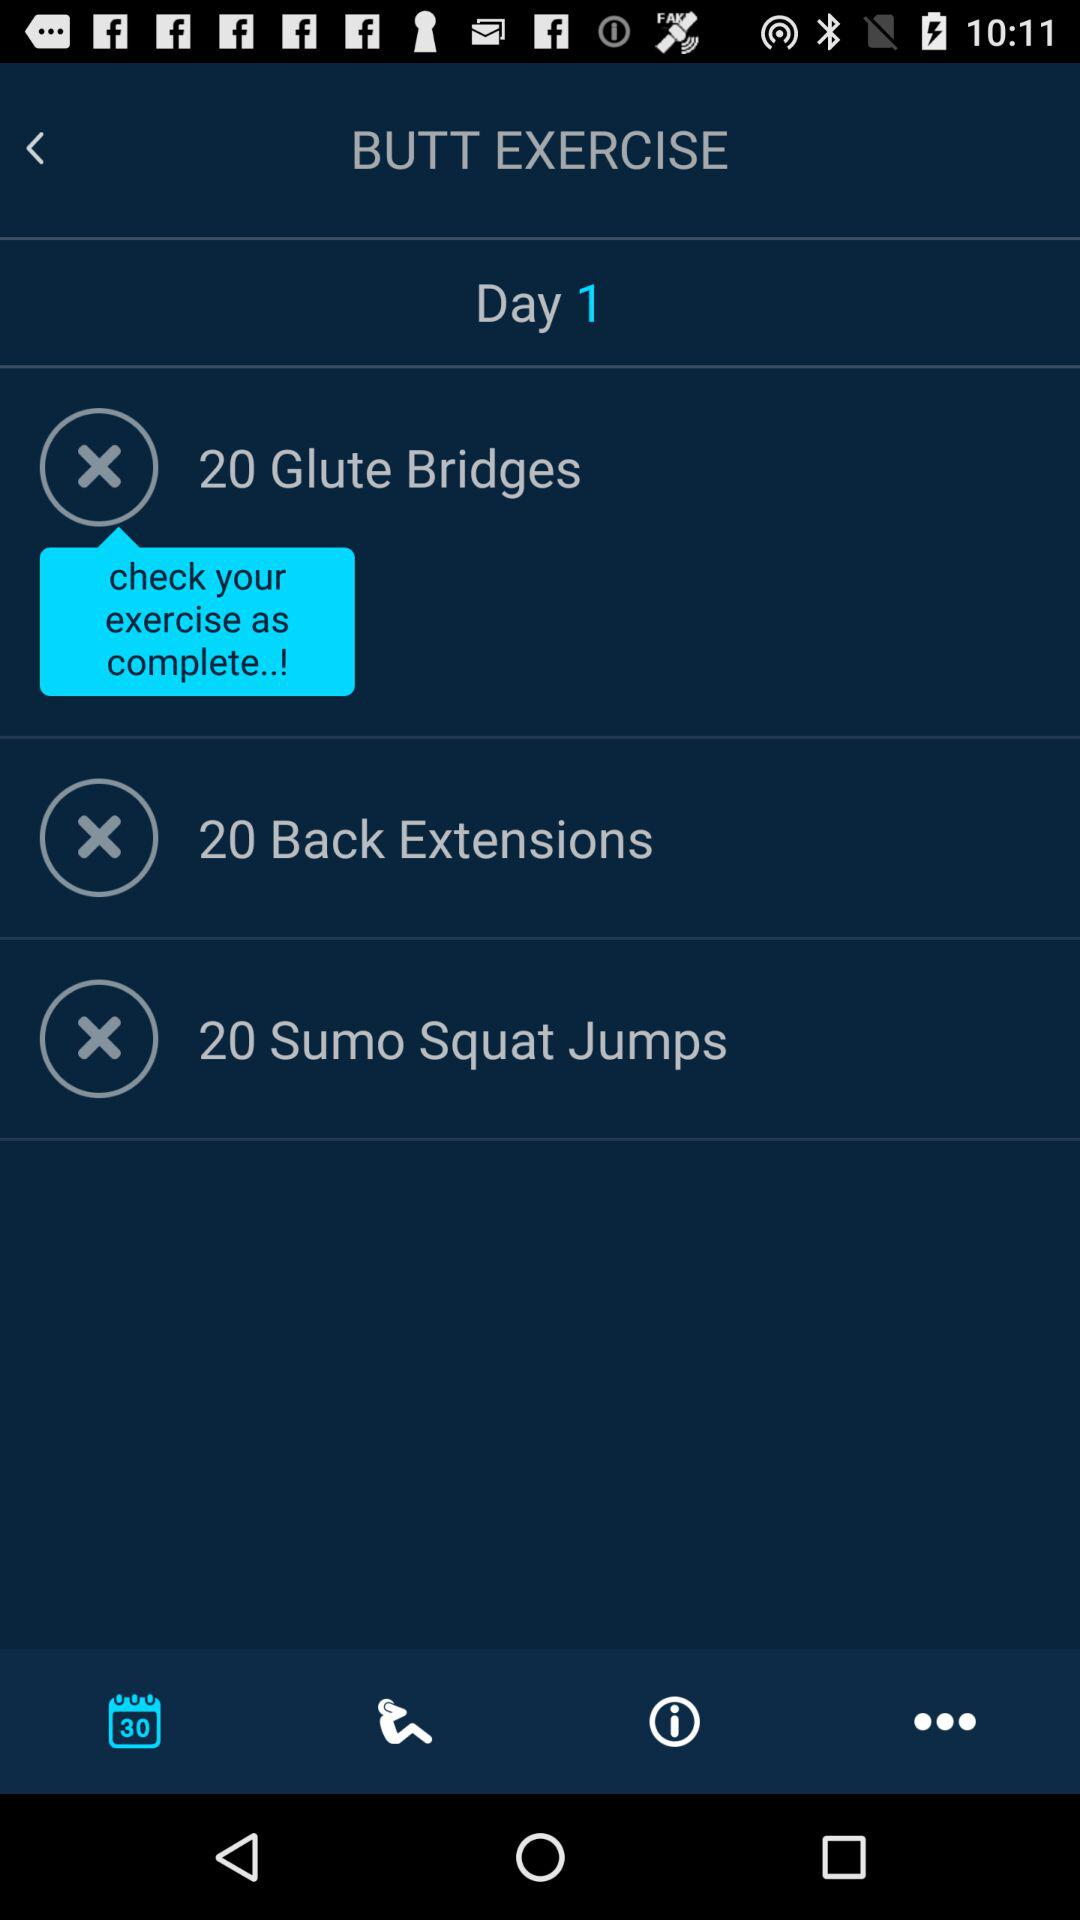How many exercises are in this workout?
Answer the question using a single word or phrase. 3 